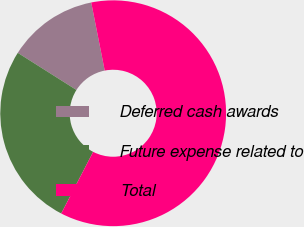<chart> <loc_0><loc_0><loc_500><loc_500><pie_chart><fcel>Deferred cash awards<fcel>Future expense related to<fcel>Total<nl><fcel>12.9%<fcel>26.37%<fcel>60.72%<nl></chart> 